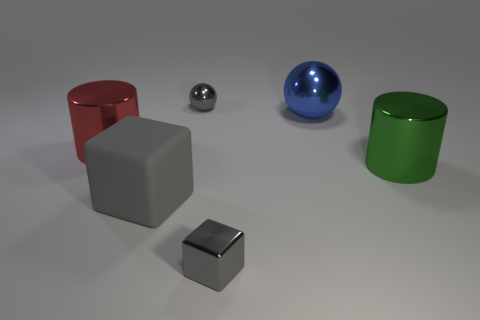Add 2 blue shiny balls. How many objects exist? 8 Subtract all cylinders. How many objects are left? 4 Add 1 green shiny cylinders. How many green shiny cylinders are left? 2 Add 2 big matte blocks. How many big matte blocks exist? 3 Subtract 1 blue balls. How many objects are left? 5 Subtract all large cylinders. Subtract all large red shiny things. How many objects are left? 3 